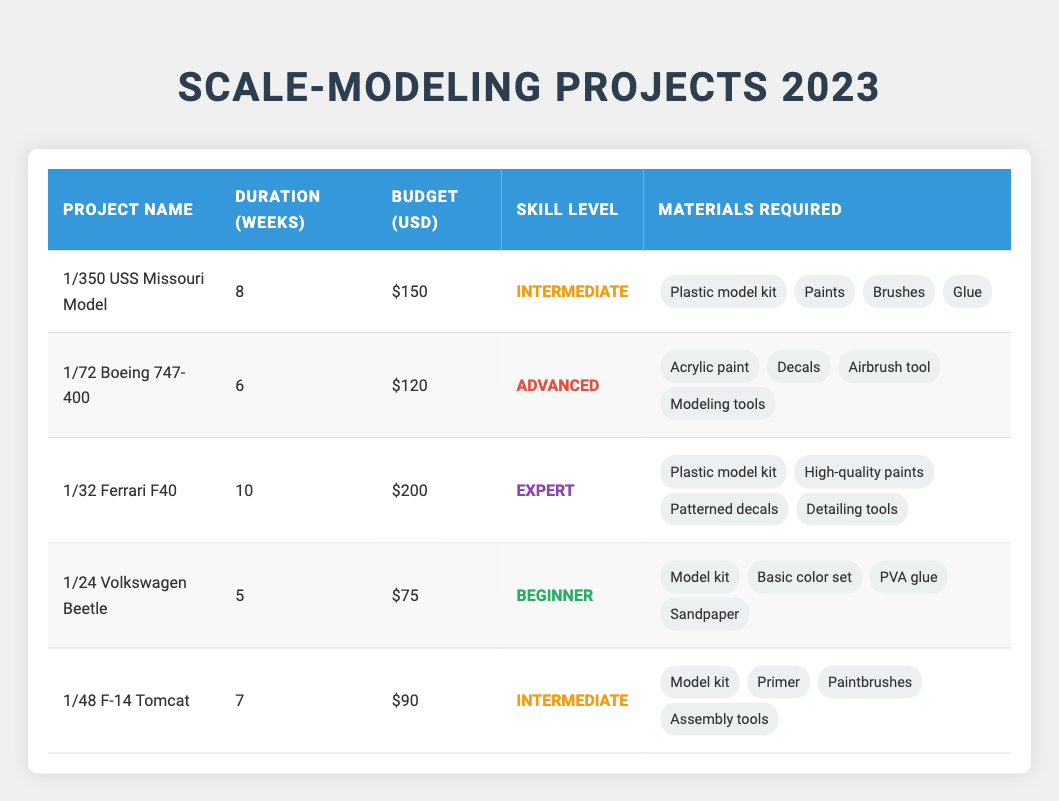What is the budget for the 1/24 Volkswagen Beetle project? The budget for the 1/24 Volkswagen Beetle project can be found in the corresponding row of the table. It shows that the budget is listed as $75.
Answer: $75 Which project has the longest duration? By looking at the duration column, I can see that the projects have durations of 8, 6, 10, 5, and 7 weeks. The maximum value here is 10 weeks, which corresponds to the 1/32 Ferrari F40 model.
Answer: 1/32 Ferrari F40 How many materials are required for the 1/350 USS Missouri Model project? Checking the materials required for the 1/350 USS Missouri Model project, it lists four items: Plastic model kit, Paints, Brushes, and Glue. Therefore, it requires four materials in total.
Answer: 4 Is the skill level for the 1/72 Boeing 747-400 project classified as beginner? The skill level listed for the 1/72 Boeing 747-400 project is Advanced. Since Advanced is not the same as Beginner, the answer to this question is No.
Answer: No What is the average budget of all scale-model projects listed? To calculate the average budget, I first sum the budgets of all projects: 150 + 120 + 200 + 75 + 90 = 635. There are 5 projects, so I divide the total budget by the number of projects, giving me 635 / 5 = 127.
Answer: 127 Which project has a shorter duration: the 1/48 F-14 Tomcat or the 1/72 Boeing 747-400? The duration for the 1/48 F-14 Tomcat is 7 weeks, while the 1/72 Boeing 747-400 has a duration of 6 weeks. Since 6 is less than 7, this shows that the 1/72 Boeing 747-400 project has a shorter duration.
Answer: 1/72 Boeing 747-400 Are there more projects classified as Intermediate than as Beginner? The projects categorized as Intermediate are the 1/350 USS Missouri Model and the 1/48 F-14 Tomcat (2 projects). The Beginner project is the 1/24 Volkswagen Beetle (1 project). Since 2 is greater than 1, there are more Intermediate projects.
Answer: Yes What is the total duration of all projects combined? I calculate the total duration by adding together the weeks for each project: 8 + 6 + 10 + 5 + 7 = 36 weeks. This gives the total duration of all the projects.
Answer: 36 